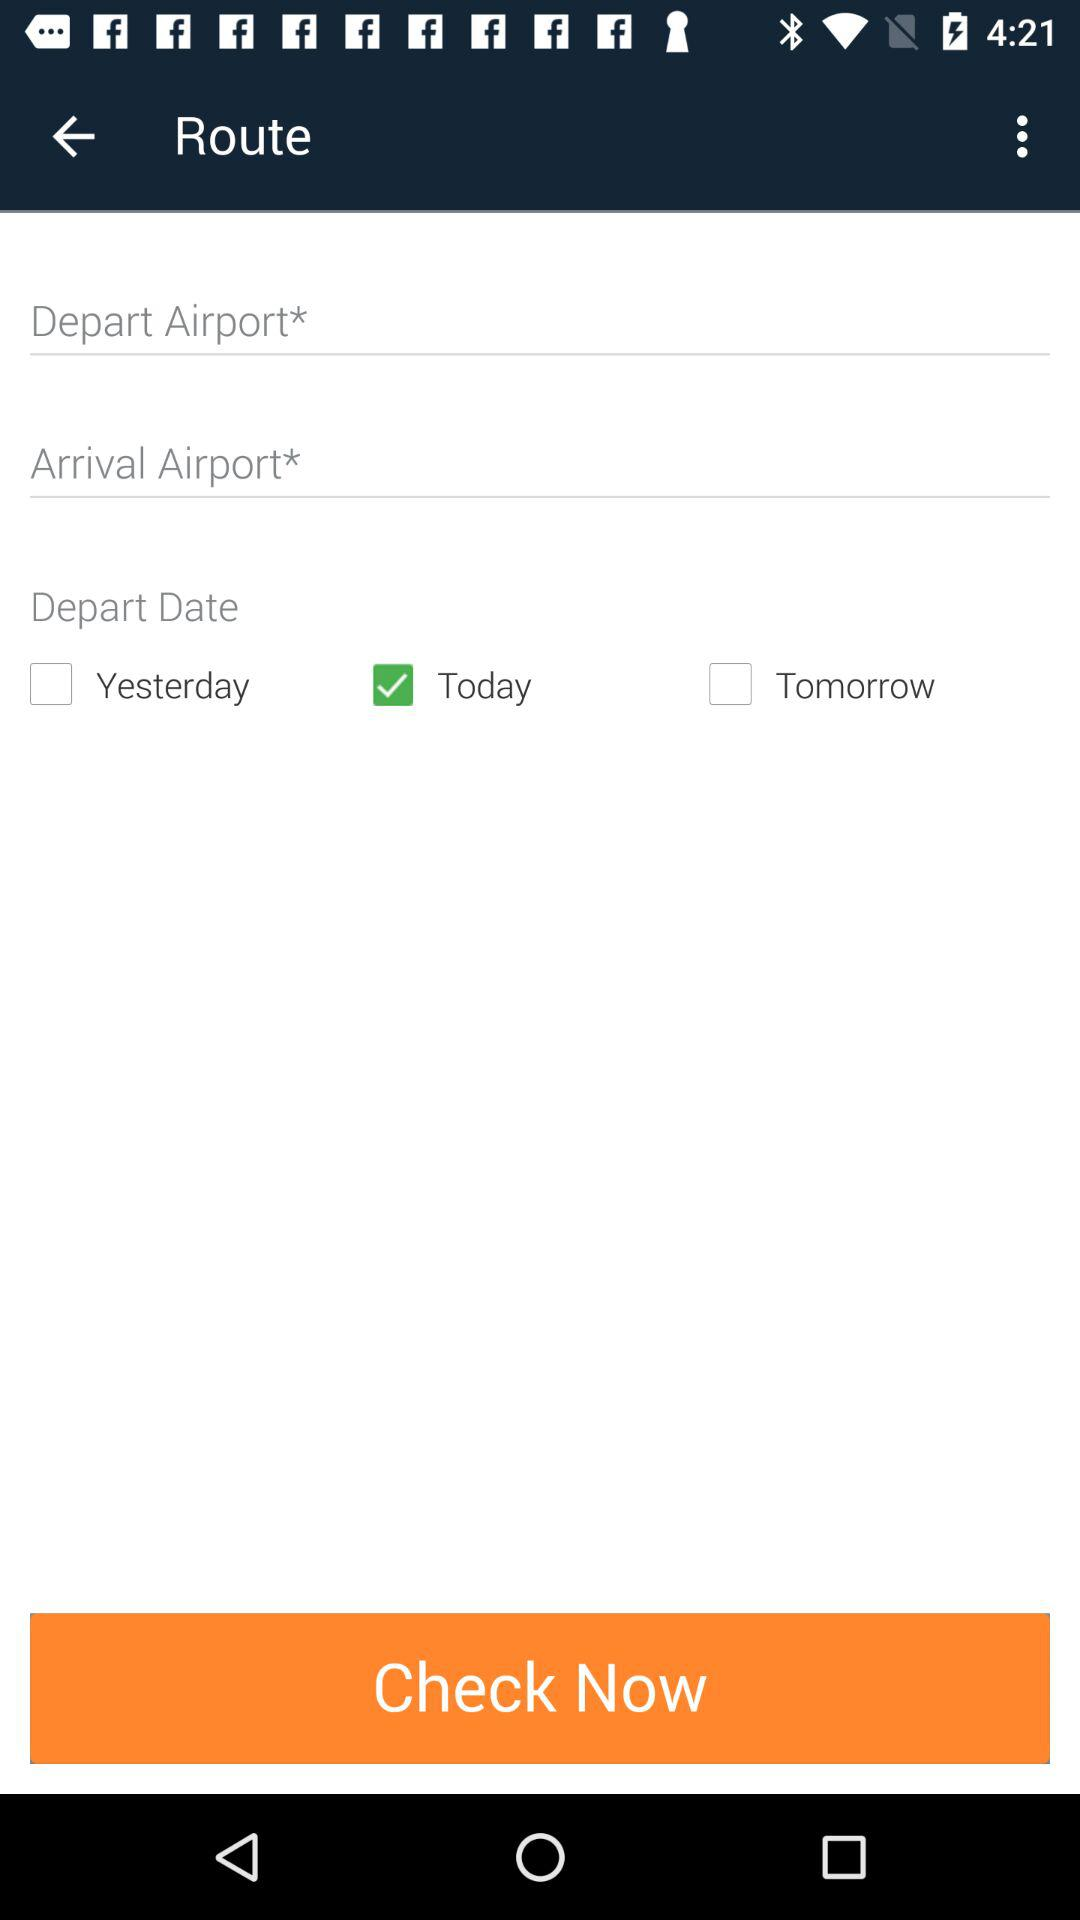Which option is selected in "Depart Date"? The selected option in "Depart Date" is "Today". 